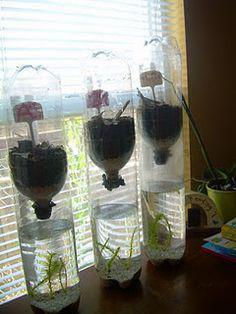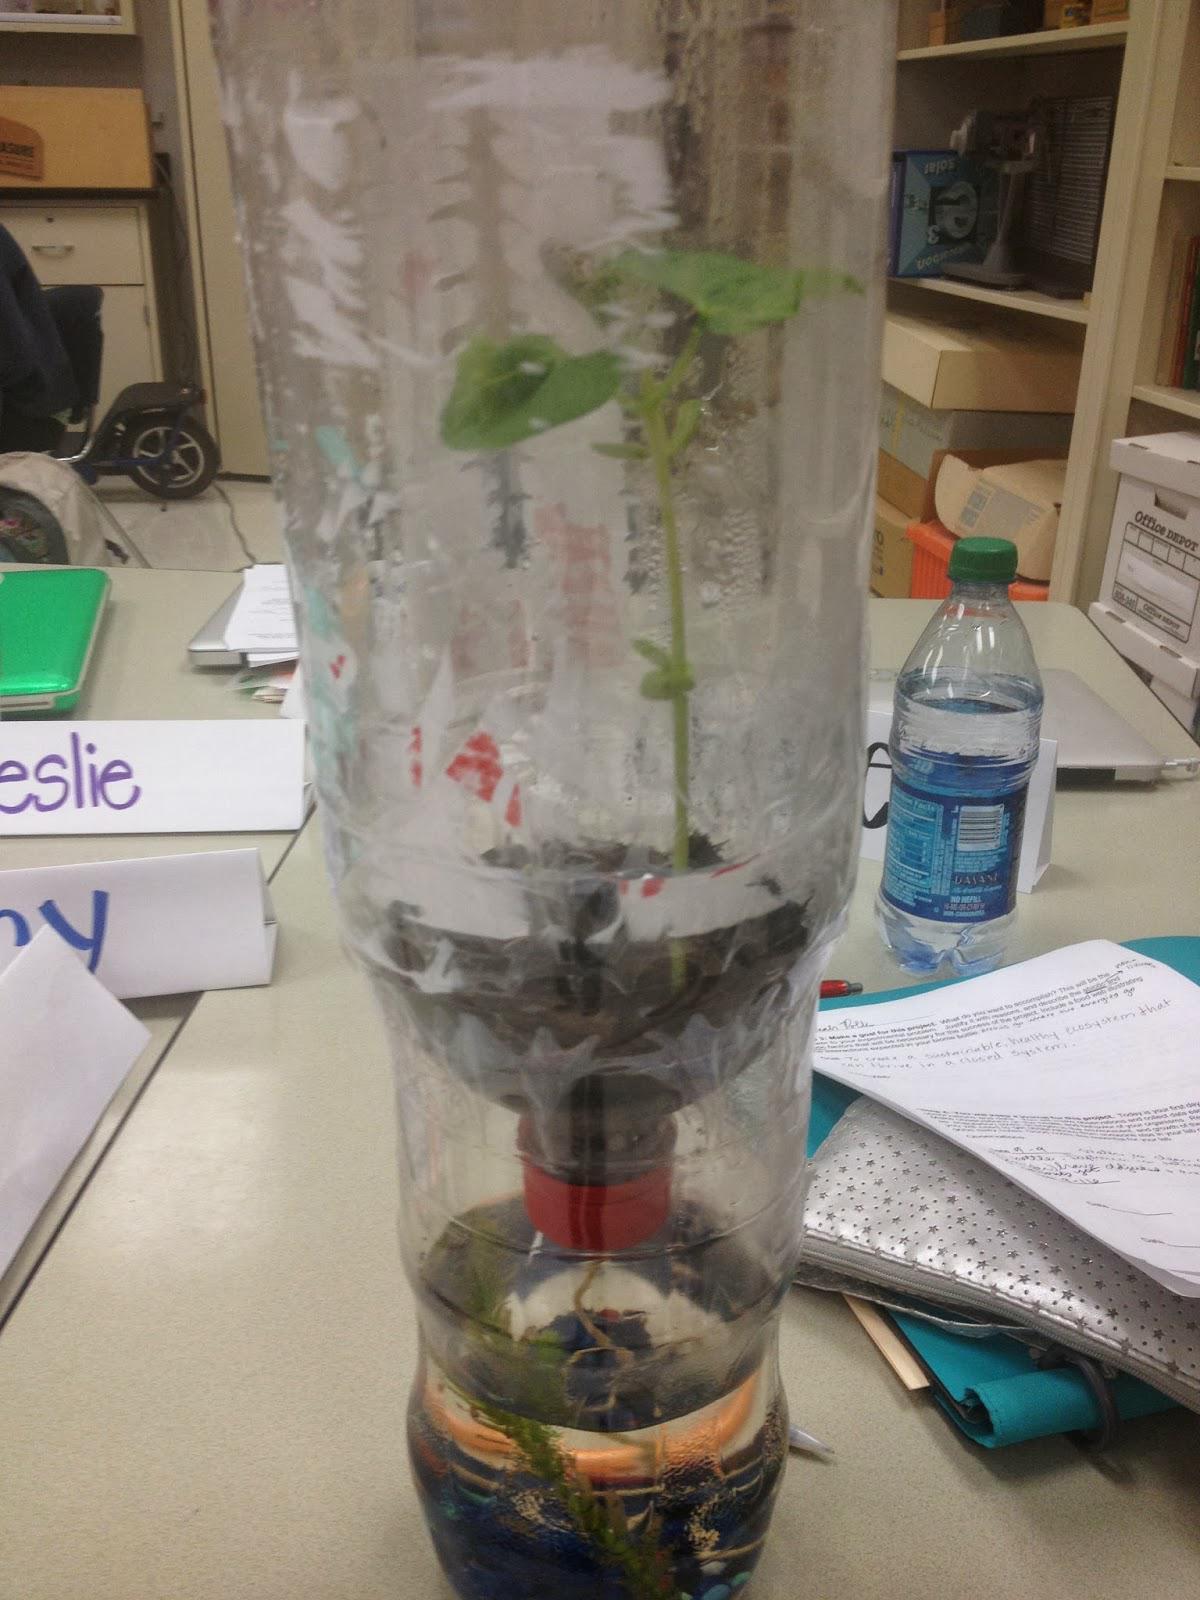The first image is the image on the left, the second image is the image on the right. Examine the images to the left and right. Is the description "The combined images contain four bottle displays with green plants in them." accurate? Answer yes or no. Yes. The first image is the image on the left, the second image is the image on the right. Analyze the images presented: Is the assertion "There are more bottles in the image on the left." valid? Answer yes or no. Yes. 